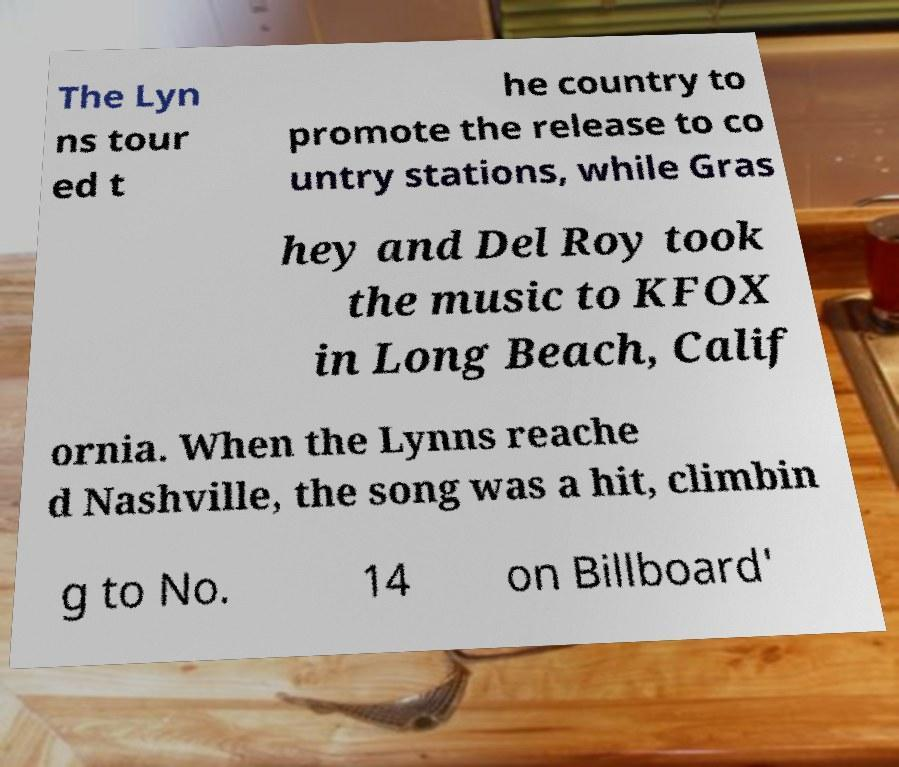There's text embedded in this image that I need extracted. Can you transcribe it verbatim? The Lyn ns tour ed t he country to promote the release to co untry stations, while Gras hey and Del Roy took the music to KFOX in Long Beach, Calif ornia. When the Lynns reache d Nashville, the song was a hit, climbin g to No. 14 on Billboard' 